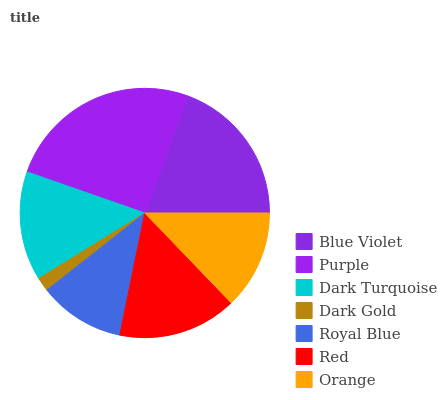Is Dark Gold the minimum?
Answer yes or no. Yes. Is Purple the maximum?
Answer yes or no. Yes. Is Dark Turquoise the minimum?
Answer yes or no. No. Is Dark Turquoise the maximum?
Answer yes or no. No. Is Purple greater than Dark Turquoise?
Answer yes or no. Yes. Is Dark Turquoise less than Purple?
Answer yes or no. Yes. Is Dark Turquoise greater than Purple?
Answer yes or no. No. Is Purple less than Dark Turquoise?
Answer yes or no. No. Is Dark Turquoise the high median?
Answer yes or no. Yes. Is Dark Turquoise the low median?
Answer yes or no. Yes. Is Orange the high median?
Answer yes or no. No. Is Royal Blue the low median?
Answer yes or no. No. 